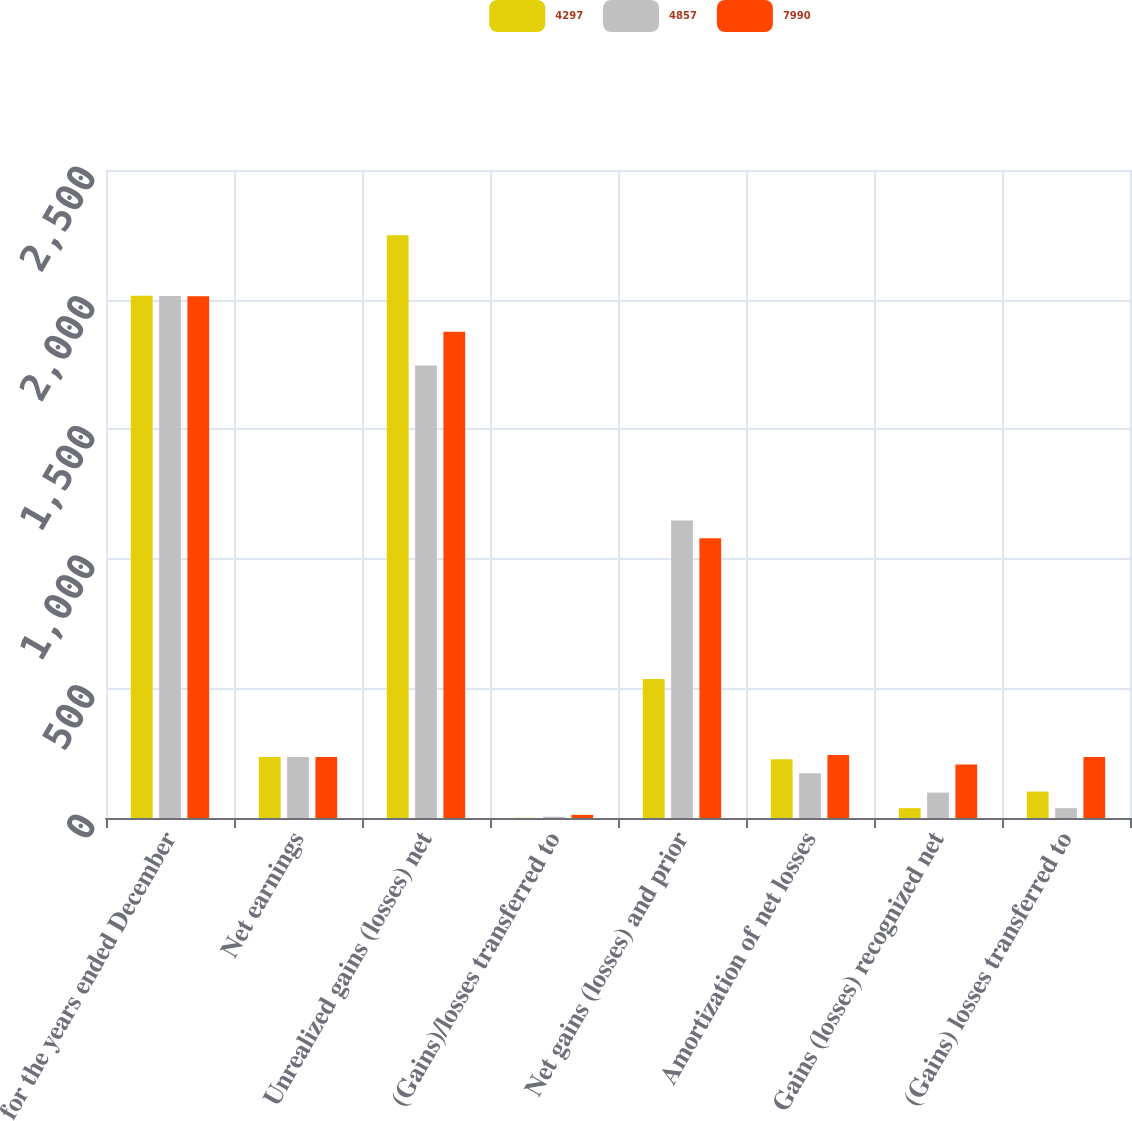Convert chart to OTSL. <chart><loc_0><loc_0><loc_500><loc_500><stacked_bar_chart><ecel><fcel>for the years ended December<fcel>Net earnings<fcel>Unrealized gains (losses) net<fcel>(Gains)/losses transferred to<fcel>Net gains (losses) and prior<fcel>Amortization of net losses<fcel>Gains (losses) recognized net<fcel>(Gains) losses transferred to<nl><fcel>4297<fcel>2015<fcel>235<fcel>2248<fcel>1<fcel>536<fcel>227<fcel>38<fcel>102<nl><fcel>4857<fcel>2014<fcel>235<fcel>1746<fcel>5<fcel>1148<fcel>173<fcel>98<fcel>38<nl><fcel>7990<fcel>2013<fcel>235<fcel>1876<fcel>12<fcel>1079<fcel>243<fcel>206<fcel>235<nl></chart> 